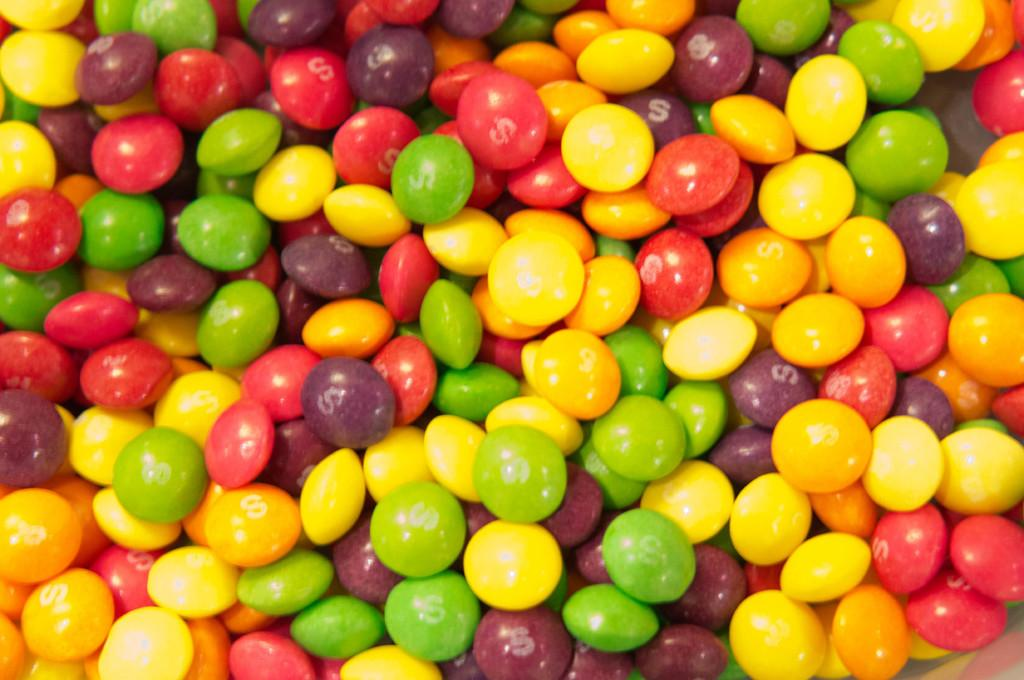What is the main subject of the image? There is a food item in the image. Can you describe the appearance of the food item? The food item resembles candy. Can you tell me how many carts are visible in the image? There are no carts present in the image; it only features a food item that resembles candy. What type of ground is visible beneath the food item in the image? There is no ground visible in the image; it only features the food item that resembles candy. 